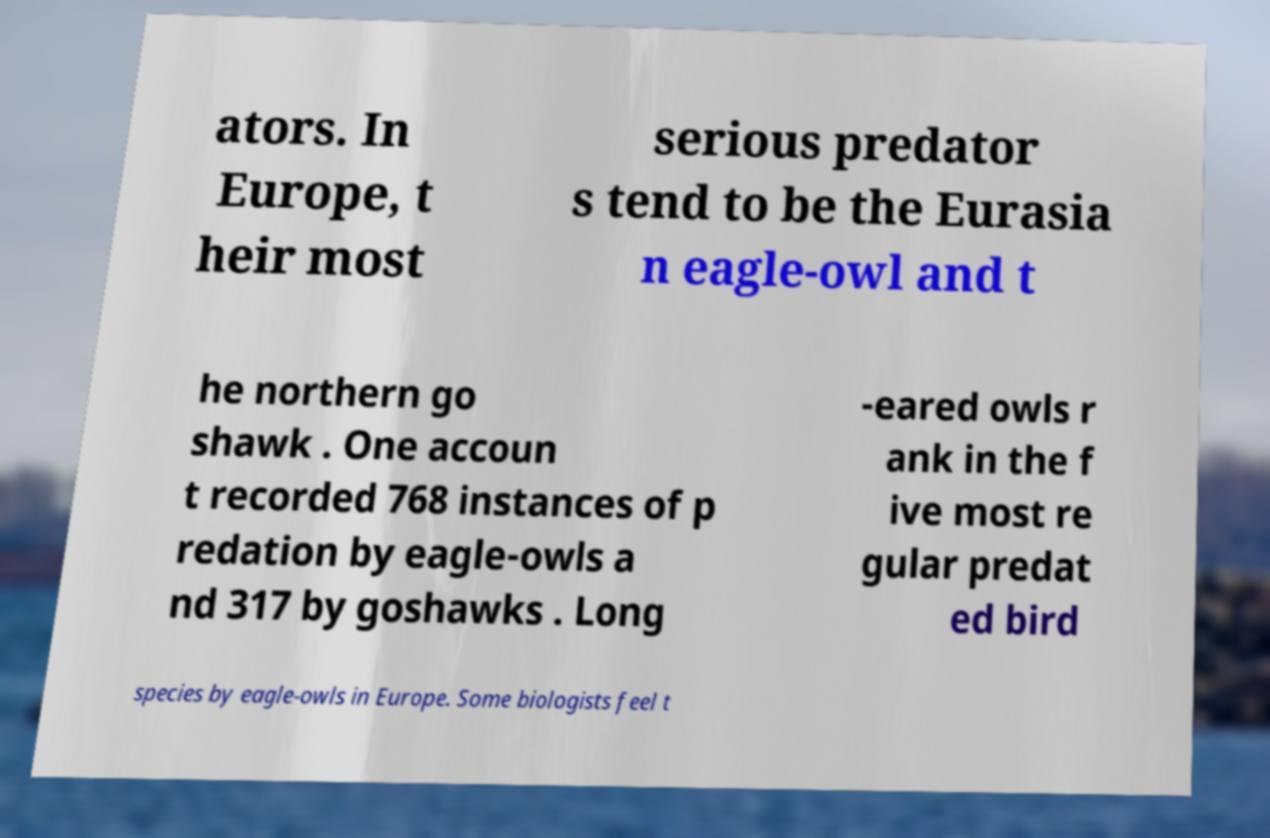Please identify and transcribe the text found in this image. ators. In Europe, t heir most serious predator s tend to be the Eurasia n eagle-owl and t he northern go shawk . One accoun t recorded 768 instances of p redation by eagle-owls a nd 317 by goshawks . Long -eared owls r ank in the f ive most re gular predat ed bird species by eagle-owls in Europe. Some biologists feel t 